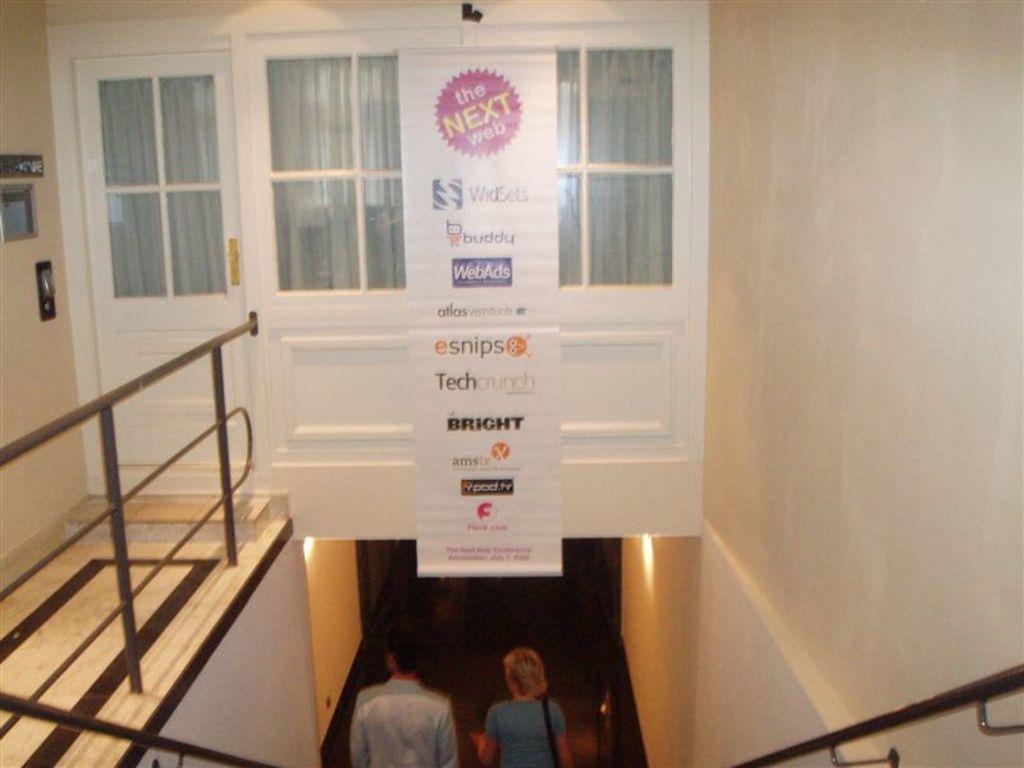Describe this image in one or two sentences. In this image there are two person truncated towards the bottom of the image, there is wall truncated towards the right of the image, there are windows, there is the door, there is a banner, there is text on the banner, there is a wall truncated towards the left of the image, there are objects on the wall, there are lights on the wall. 